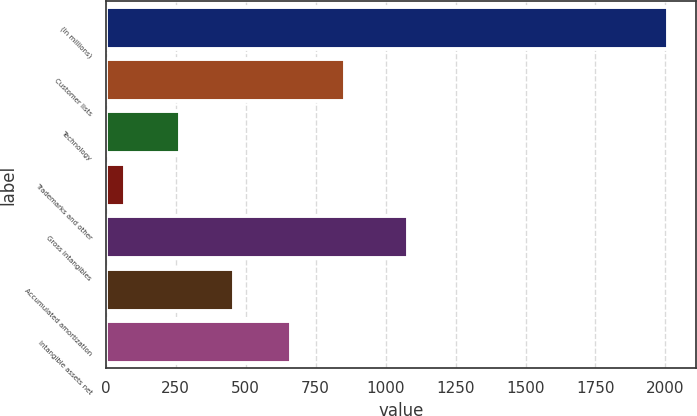Convert chart to OTSL. <chart><loc_0><loc_0><loc_500><loc_500><bar_chart><fcel>(In millions)<fcel>Customer lists<fcel>Technology<fcel>Trademarks and other<fcel>Gross intangibles<fcel>Accumulated amortization<fcel>Intangible assets net<nl><fcel>2009<fcel>854.9<fcel>263.9<fcel>70<fcel>1081<fcel>457.8<fcel>661<nl></chart> 